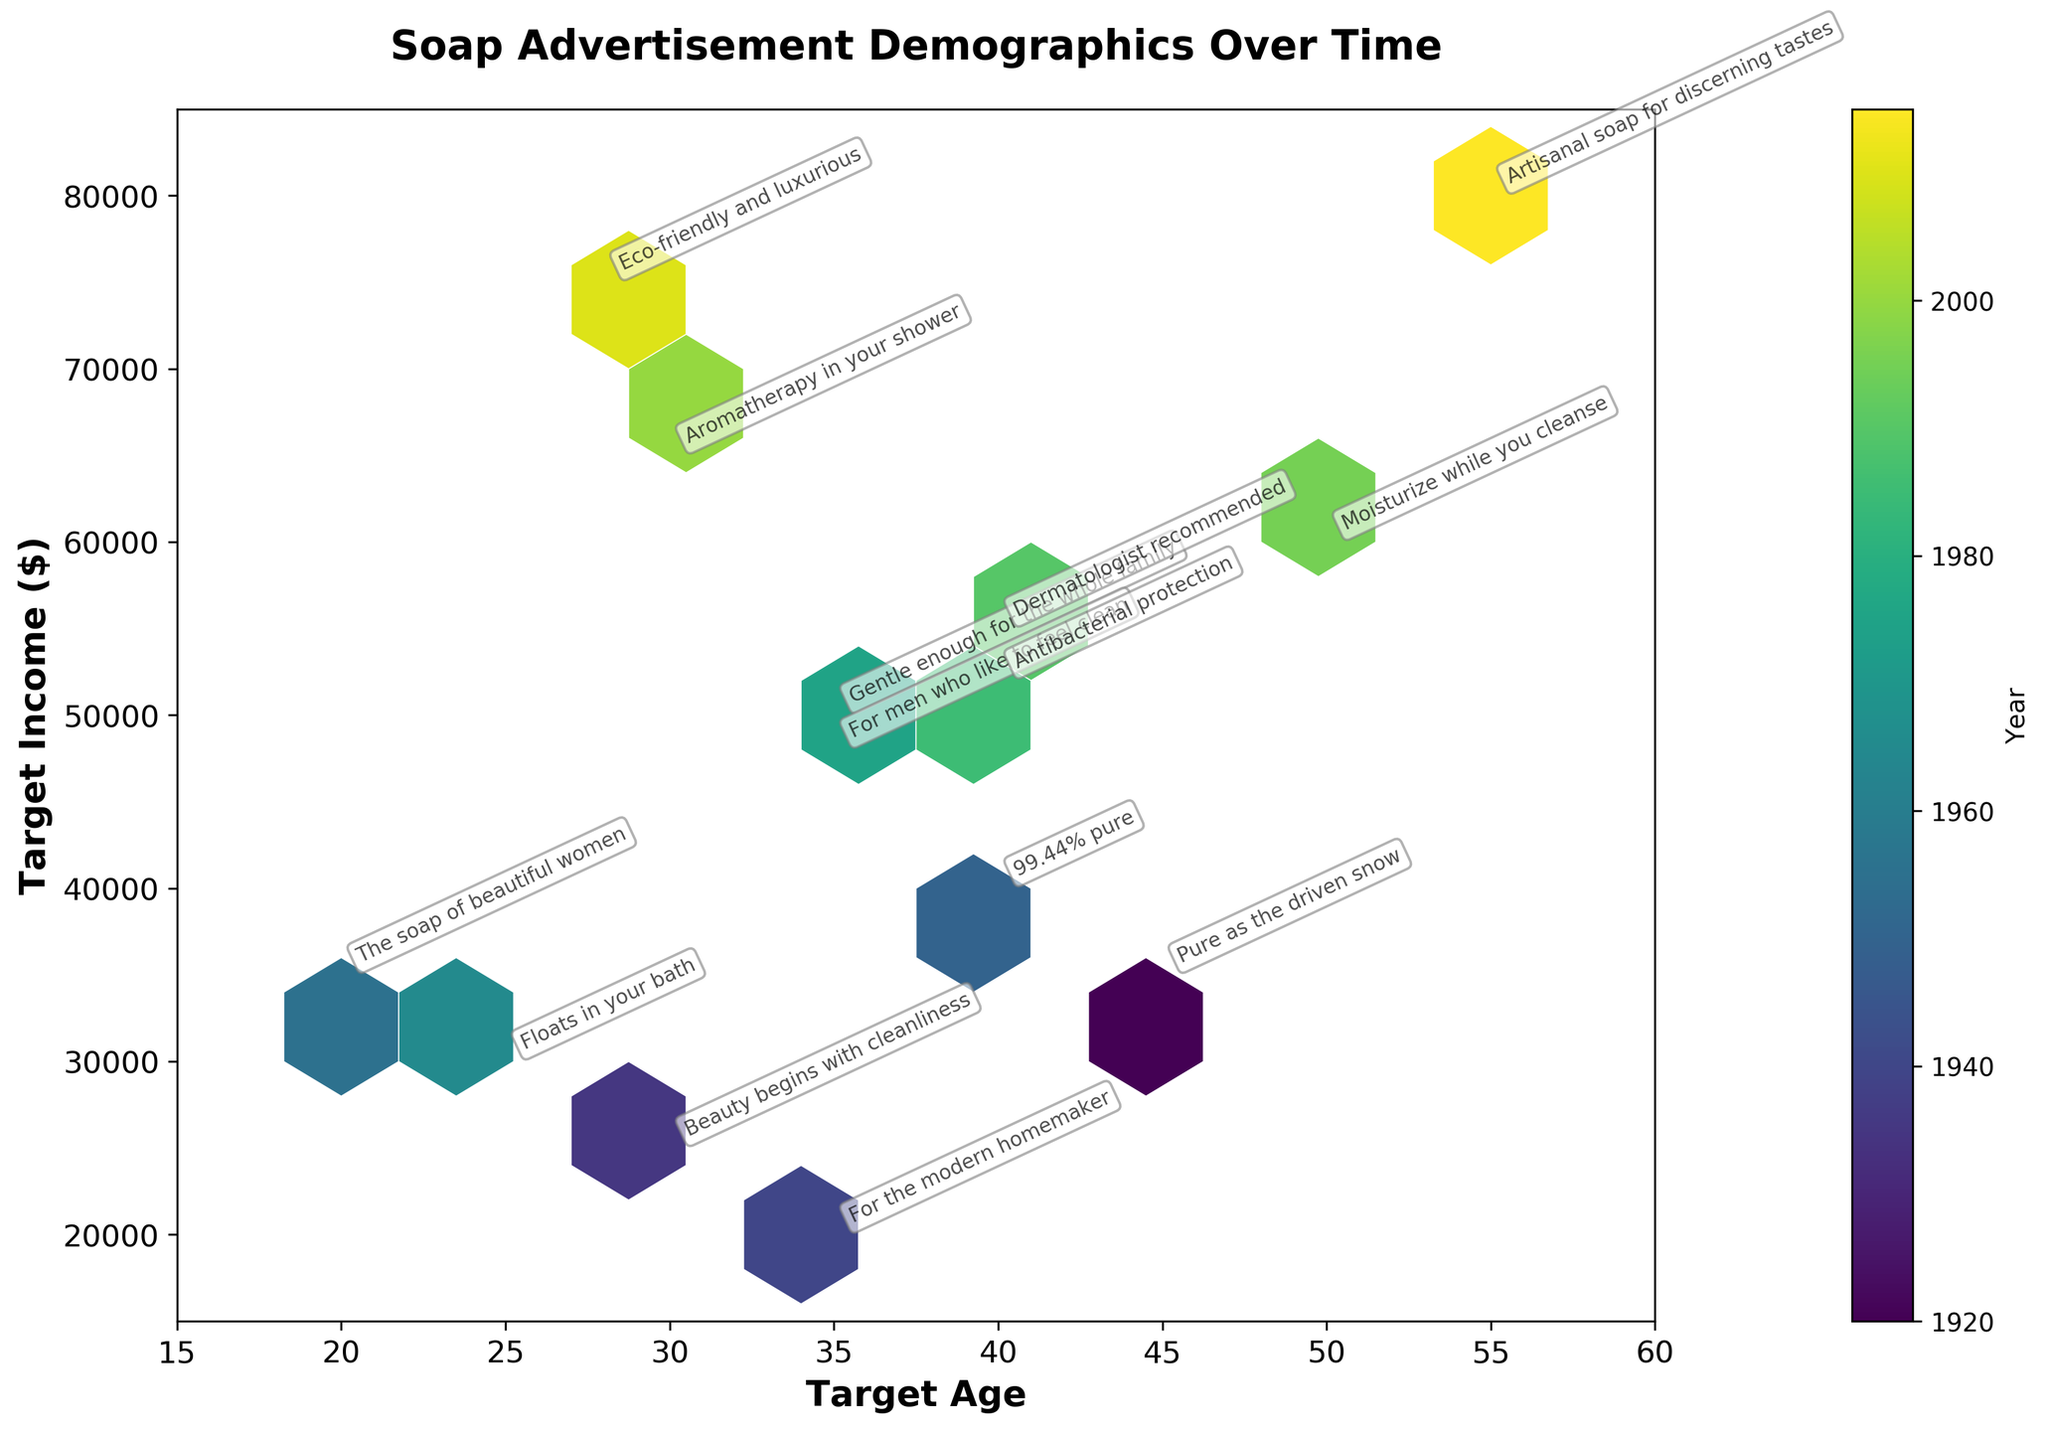what is the title of the plot? The title of the plot is typically displayed at the top of the figure, serving to summarize the main topic or insight.
Answer: Soap Advertisement Demographics Over Time What age group is mostly associated with the slogan "Moisturize while you cleanse"? Locate the slogan annotation "Moisturize while you cleanse" on the plot and note its position relative to the Target_Age axis.
Answer: 50 How many data points are present? Data points in the Hexbin Plot are indicated by the hexagon bins and their contents. Each slogan annotation represents a data point that can be counted.
Answer: 14 Which target income has the highest frequency for the target age between 30 to 40? Observe the color intensity in the hexagon bins between ages 30 to 40 and note which income range has the most bins.
Answer: 35,000 to 50,000 What is the highest income associated with the slogans in the plot? Look for the highest value on the Target_Income axis that has an associated slogan annotation.
Answer: 80,000 Is there a visible trend in target income over the years? Examine the color gradient representing years from left to right. Generally, see if the target income tends to increase or decrease over time.
Answer: Increasing Which slogan targets the youngest demographic? Find the slogan annotation closest to the minimum value on the Target_Age axis.
Answer: "The soap of beautiful women" Compare the slogans targeting the age group of 40. Which slogan has the higher target income? Locate the slogans targeting age 40 ("99.44% pure" and "Dermatologist recommended"), and compare their positions on the Target_Income axis.
Answer: Dermatologist recommended What's the average target income for the slogans targeting ages 30 and 35? Identify the target income values for slogans targeting ages 30 and 35, sum them up, and then divide by the total number of these values: (25000 + 25000 + 50000 + 20000 + 48000) / 5.
Answer: 36,600 Does the target age correlate positively with the target income over the years? Assess the general trend of the plot by comparing target age and income values as years progress, and judge whether there seems to be a positive correlation.
Answer: Yes 